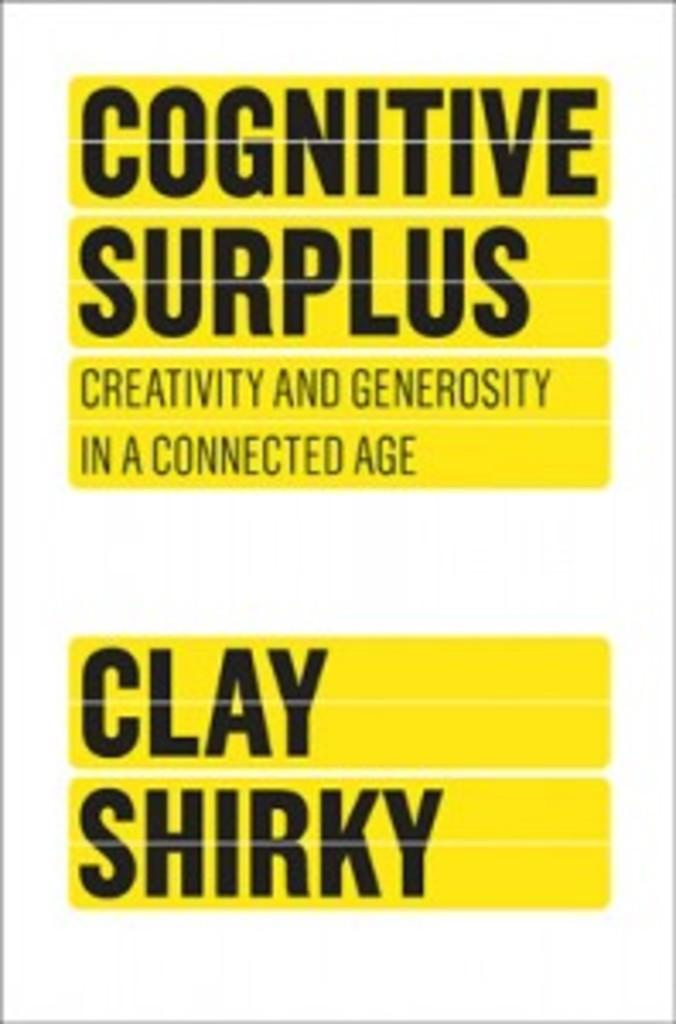<image>
Create a compact narrative representing the image presented. A book by Clay Shirky entitled "Cognitive Surplus; Creativity and generosity in a connected age". 